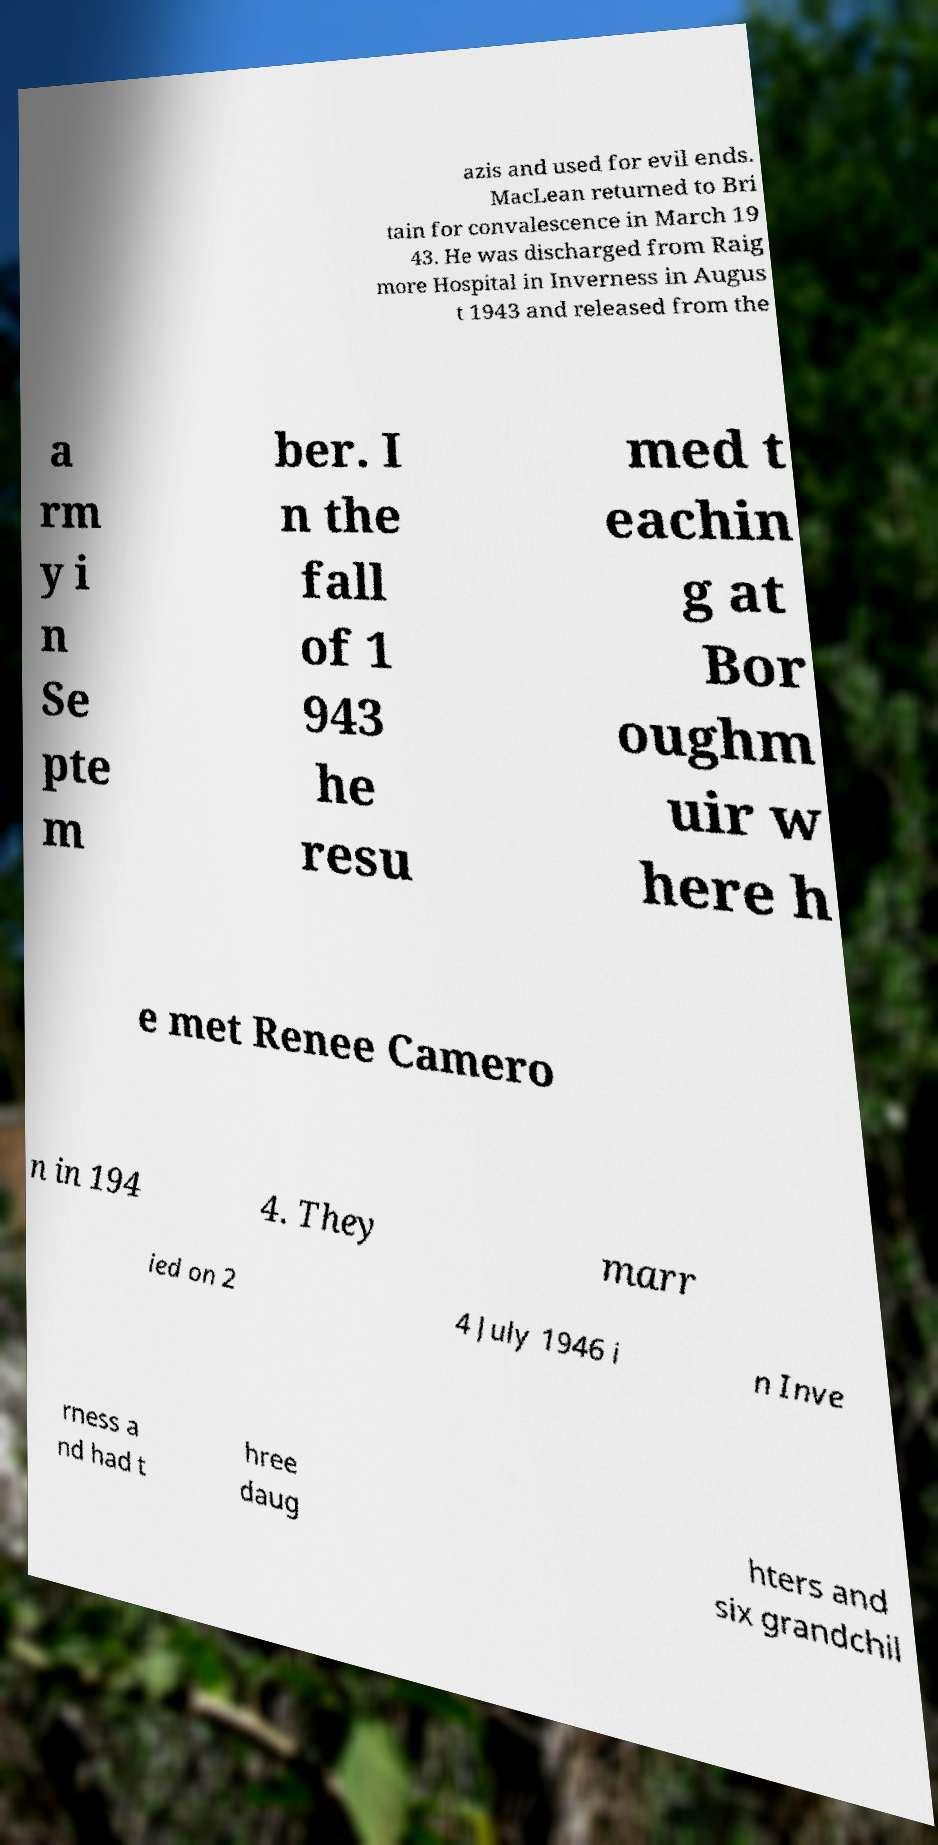There's text embedded in this image that I need extracted. Can you transcribe it verbatim? azis and used for evil ends. MacLean returned to Bri tain for convalescence in March 19 43. He was discharged from Raig more Hospital in Inverness in Augus t 1943 and released from the a rm y i n Se pte m ber. I n the fall of 1 943 he resu med t eachin g at Bor oughm uir w here h e met Renee Camero n in 194 4. They marr ied on 2 4 July 1946 i n Inve rness a nd had t hree daug hters and six grandchil 